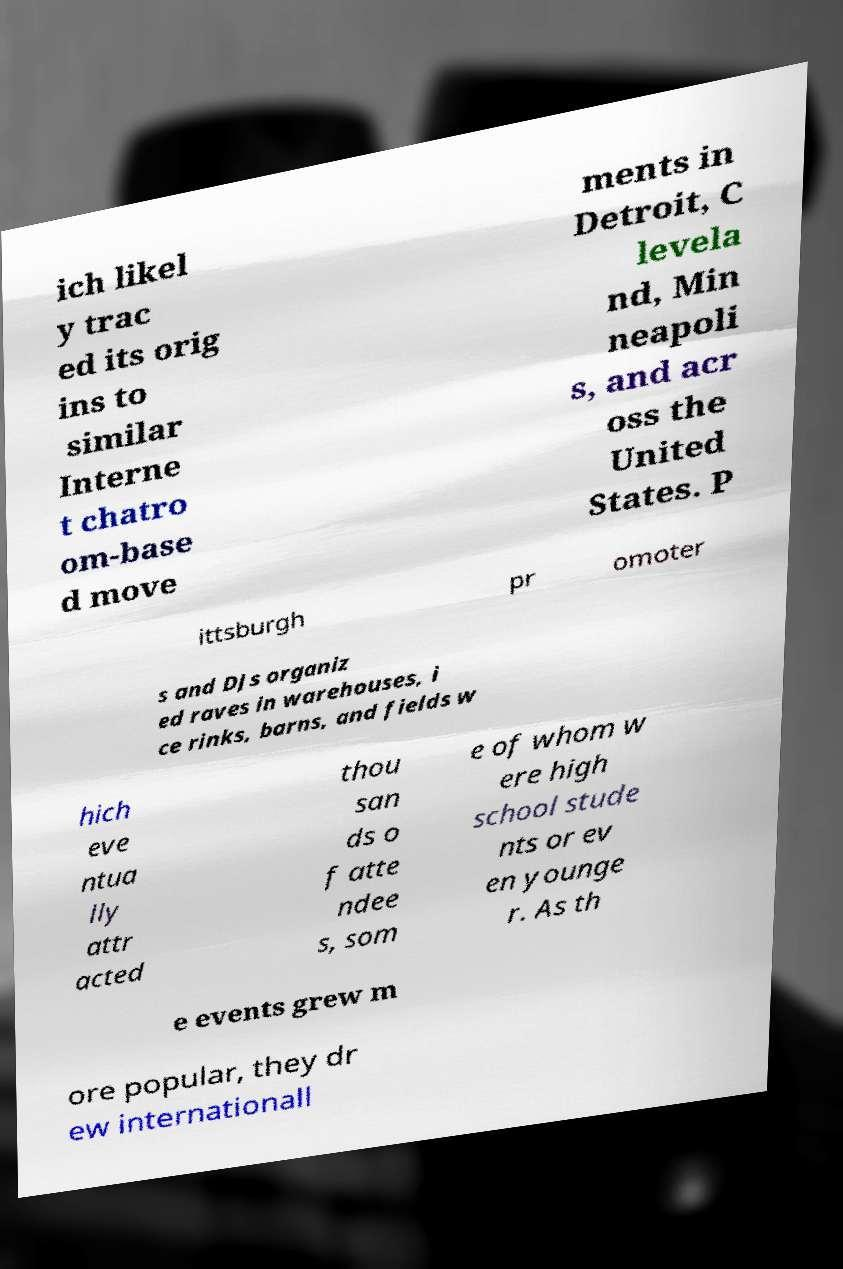Can you accurately transcribe the text from the provided image for me? ich likel y trac ed its orig ins to similar Interne t chatro om-base d move ments in Detroit, C levela nd, Min neapoli s, and acr oss the United States. P ittsburgh pr omoter s and DJs organiz ed raves in warehouses, i ce rinks, barns, and fields w hich eve ntua lly attr acted thou san ds o f atte ndee s, som e of whom w ere high school stude nts or ev en younge r. As th e events grew m ore popular, they dr ew internationall 